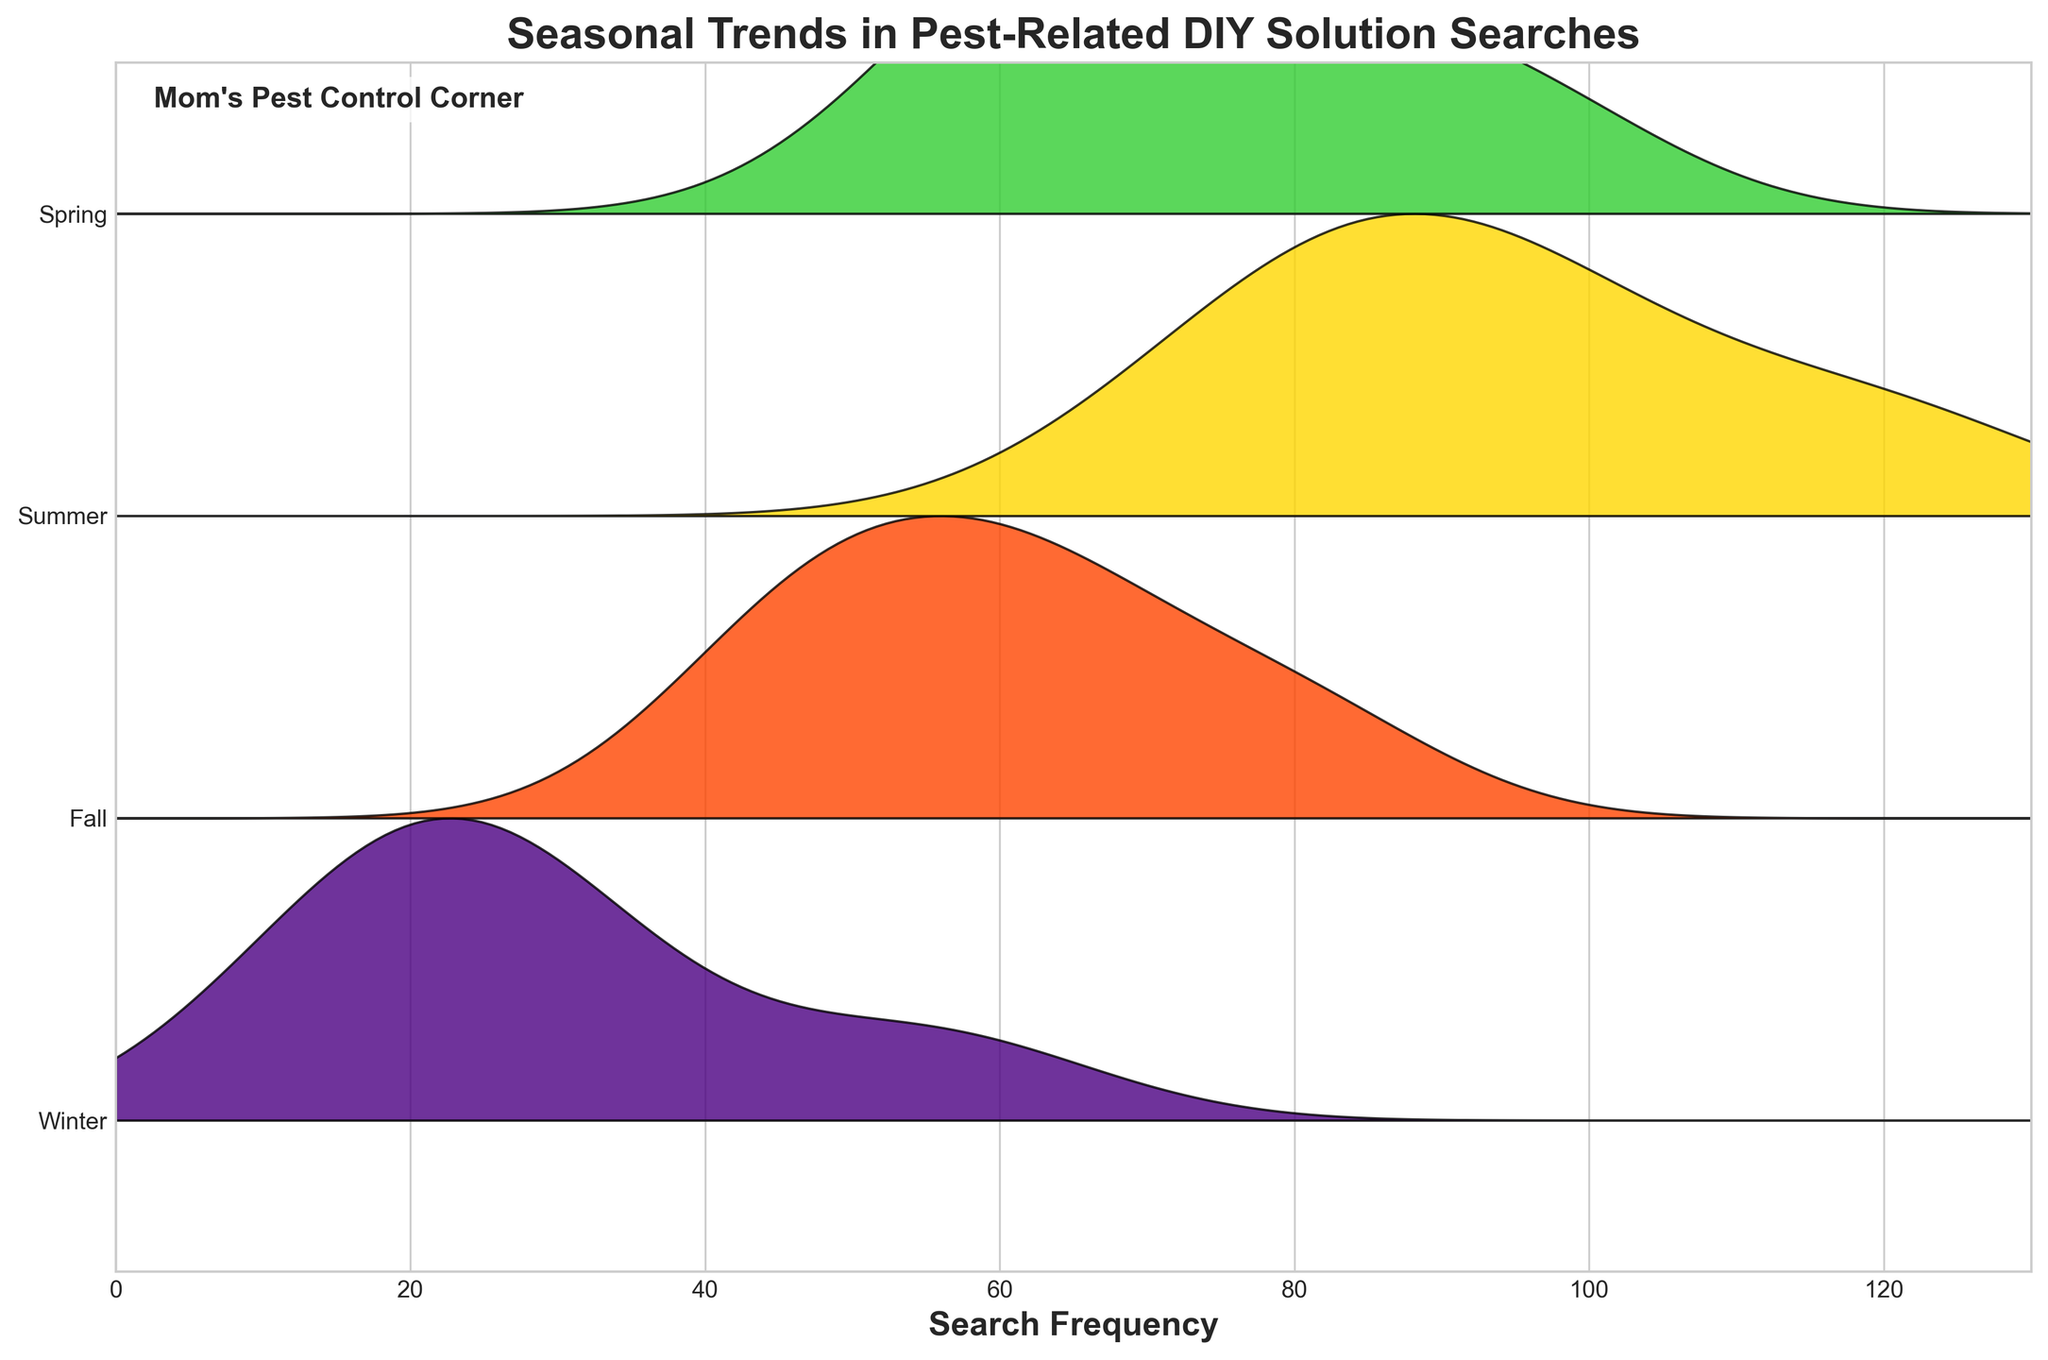What is the title of the figure? The title is displayed at the top of the plot, giving context to what the plot represents. It's clearly written above the rest of the figure.
Answer: Seasonal Trends in Pest-Related DIY Solution Searches Which season has the highest search frequency for DIY mosquito repellents? By observing the ridgeline plot, we can compare the peaks of the KDE curves for DIY mosquito repellents across all seasons. The tallest peak indicates the highest frequency.
Answer: Summer How does the search frequency for natural wasp deterrents compare between Spring and Winter? By examining the heights of the ridgeline plots for natural wasp deterrents in both Spring and Winter, we see that Spring has a higher peak.
Answer: Higher in Spring In which season are DIY ant repellent searches more frequent, Summer or Fall? Looking at the ridgeline plot, we compare the peaks for DIY ant repellents between Summer and Fall. The one with the taller peak shows higher frequency.
Answer: Summer What can be inferred about the search frequency for homemade fruit fly traps in Winter? From the ridgeline plot, the KDE curve for Winter for homemade fruit fly traps has a notably lower peak compared to other seasons.
Answer: Low frequency Which season shows the lowest overall search frequencies for all pest-related DIY solutions? By comparing the overall height and density of the KDE curves across all seasons, Winter consistently has lower peaks for all categories.
Answer: Winter What is the general trend of search frequencies for DIY mosquito repellents from Spring to Winter? By observing the pattern of KDE curves for DIY mosquito repellents across the seasons, the trend starts high in Spring, peaks in Summer, and declines through Fall and Winter.
Answer: Decreasing Which DIY solution shows the most uniform search frequency across all seasons? By comparing the KDE curves of each DIY solution across all seasons, the one which exhibits the smallest variation in peak heights indicates uniform search frequencies.
Answer: Homemade roach killer Is there any season where all pest-related DIY searches have relatively high frequencies? Summarizing from the plot’s KDE curves, Summer shows high peaks across all solutions, indicating high search frequencies for all pest-related DIY solutions.
Answer: Summer 